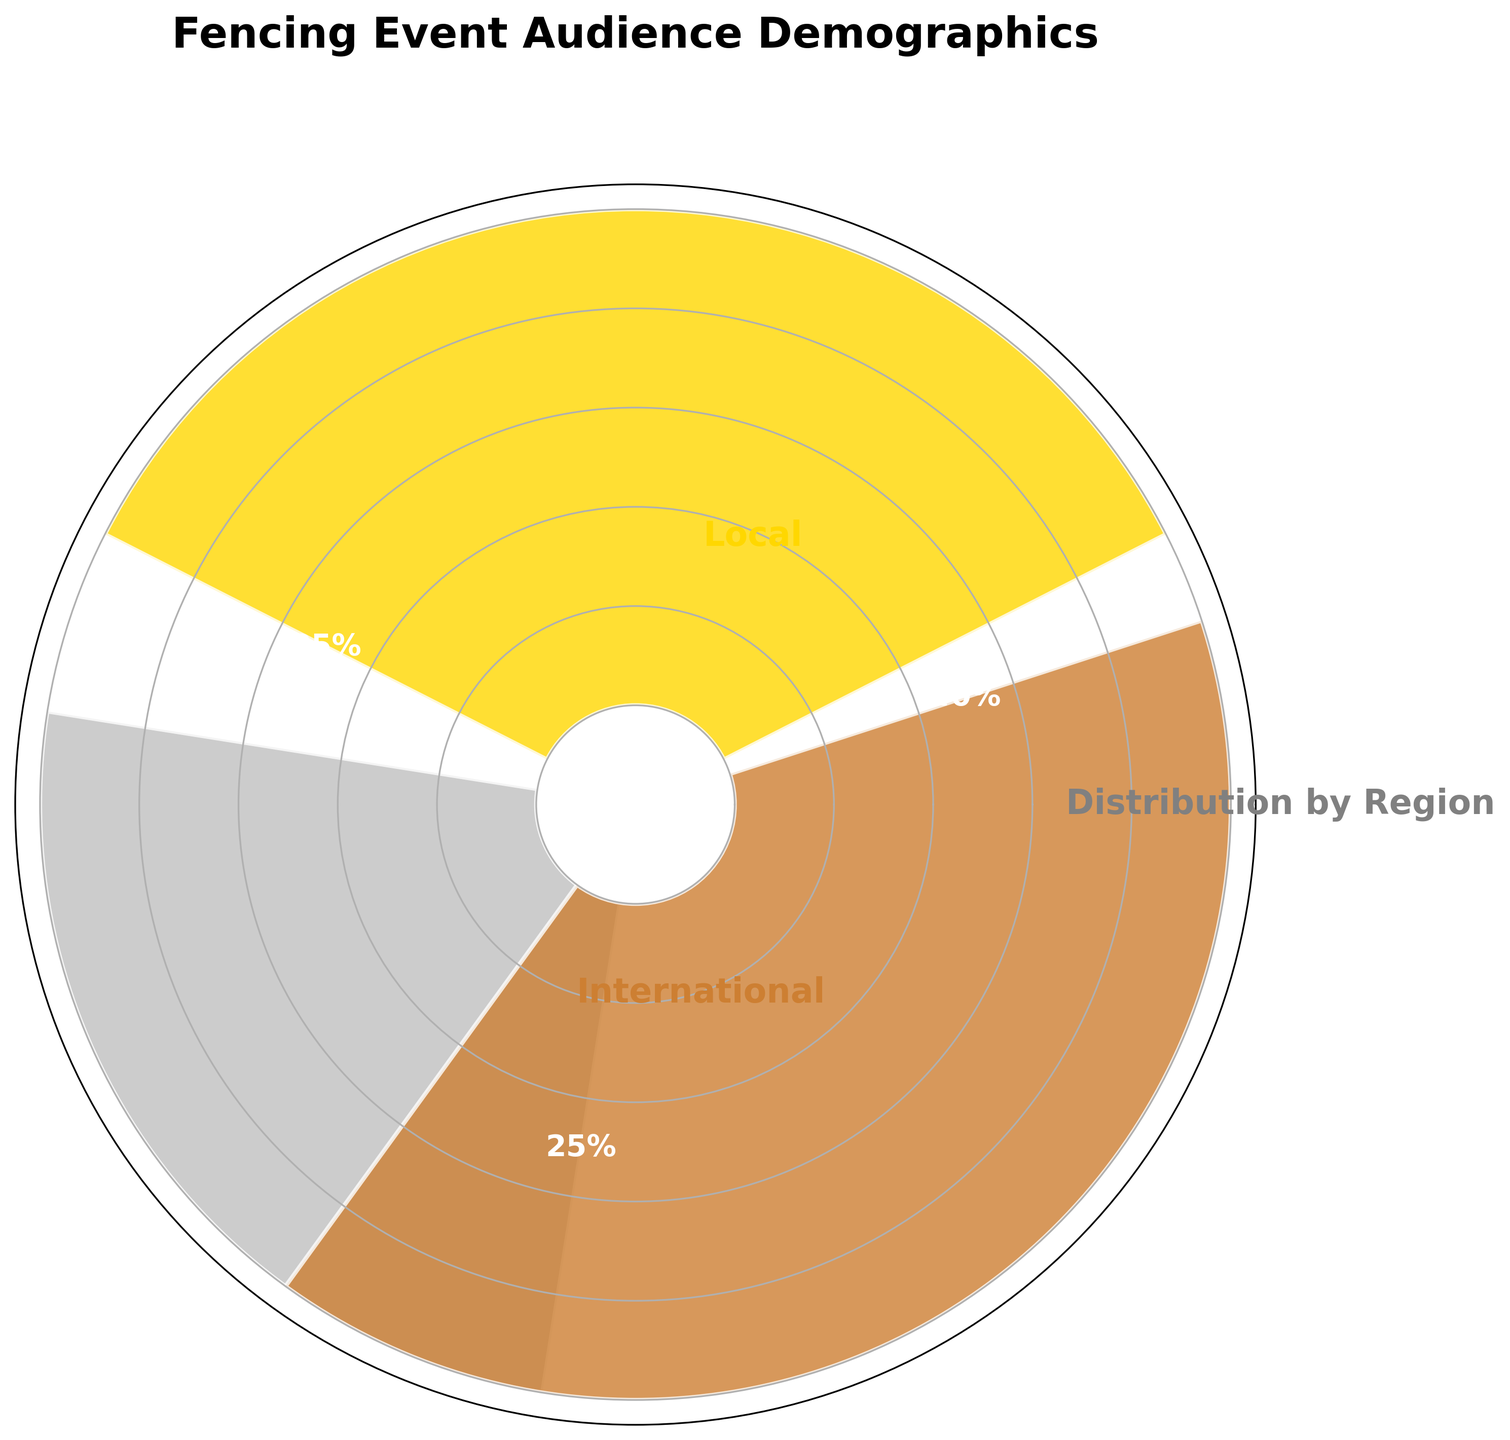What are the regions represented in the rose chart? The regions are labeled on the chart. They are Local, National, and International.
Answer: Local, National, International What is the percentage of the local audience? The percentage is displayed within the corresponding segment of the rose chart for the local audience. It is 35%.
Answer: 35% Which region has the highest audience percentage? The proportion of each regional audience is represented by the size of their respective segment on the rose chart. The International segment is the largest.
Answer: International How does the national audience percentage compare to the local audience percentage? The national audience percentage can be directly compared to the local audience percentage. The local audience percentage (35%) is higher than the national audience percentage (25%).
Answer: Less than What is the combined percentage of the national and international audiences? Add the percentages of the national and international audiences together: 25% + 40% = 65%.
Answer: 65% Which region's segment is displayed in silver color? The silver color corresponds to the National audience, as indicated by the color coding in the chart.
Answer: National What is the title of the rose chart? The title of the chart is located at the top center and reads "Fencing Event Audience Demographics."
Answer: Fencing Event Audience Demographics What percentage of the audience comes from either national or local regions? Add the percentages of the national and local audiences together: 25% + 35% = 60%.
Answer: 60% How much greater is the international audience percentage compared to the national audience percentage? Subtract the national audience percentage from the international audience percentage: 40% - 25% = 15%.
Answer: 15% Which region's audience percentage is closest to one-third of the total audience? One-third of the total audience is approximately 33.33%. The local audience percentage is 35%, which is closest to one-third.
Answer: Local 